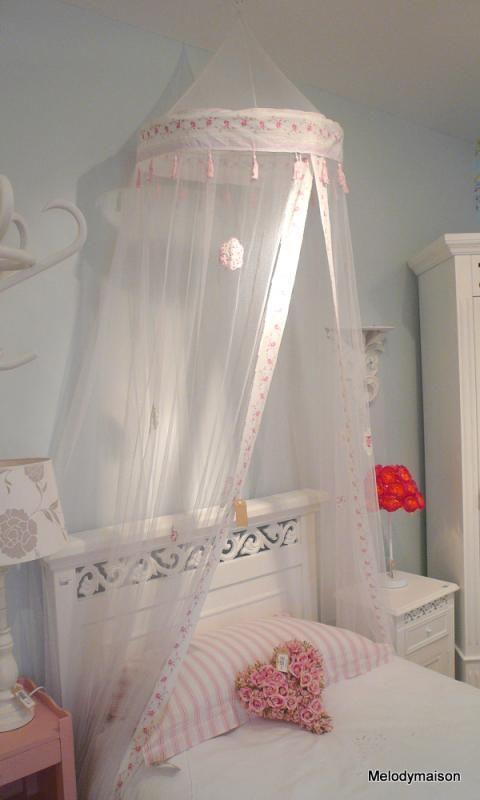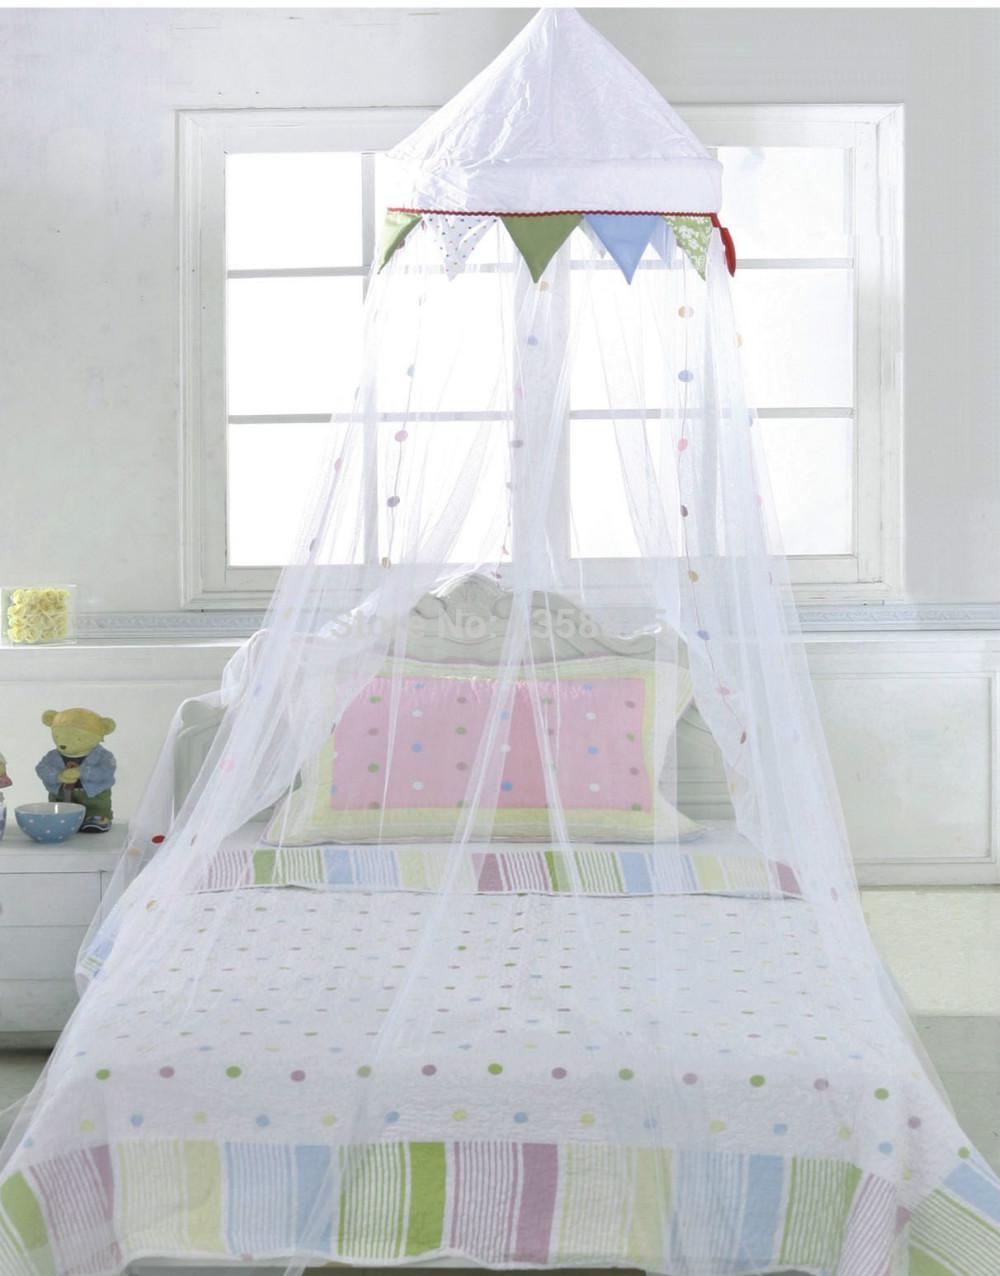The first image is the image on the left, the second image is the image on the right. Evaluate the accuracy of this statement regarding the images: "All of the curtains are draped above regular beds.". Is it true? Answer yes or no. Yes. The first image is the image on the left, the second image is the image on the right. Analyze the images presented: Is the assertion "There are two beds in total." valid? Answer yes or no. Yes. 